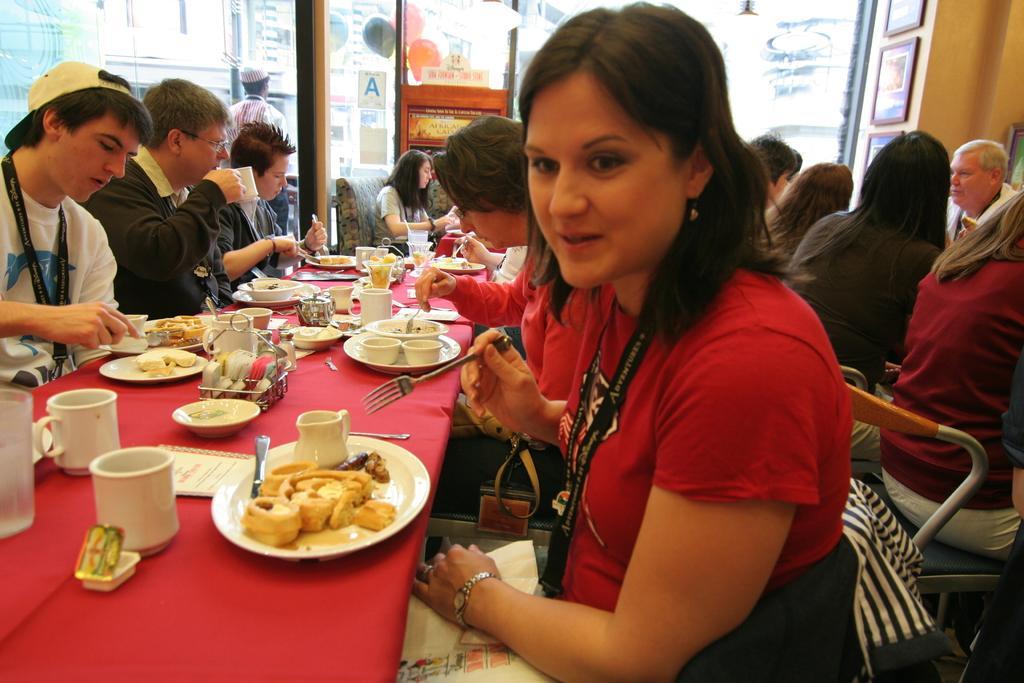Please provide a concise description of this image. In this picture there are two dining tables with two rows of people, they are having there meals and one man is there who is standing near the door staring outside from the glass window, the people those who are eating their meals they have their identity cards around there neck. 